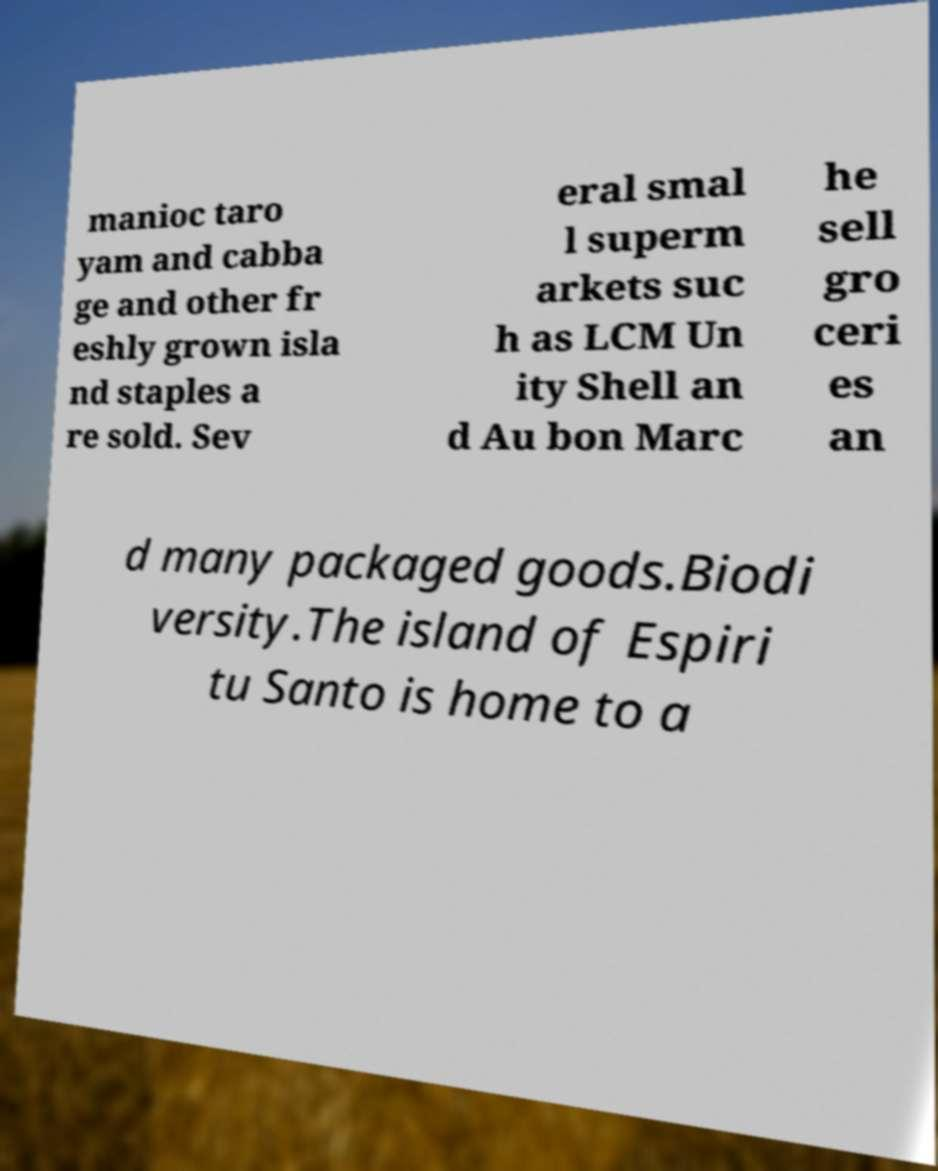There's text embedded in this image that I need extracted. Can you transcribe it verbatim? manioc taro yam and cabba ge and other fr eshly grown isla nd staples a re sold. Sev eral smal l superm arkets suc h as LCM Un ity Shell an d Au bon Marc he sell gro ceri es an d many packaged goods.Biodi versity.The island of Espiri tu Santo is home to a 